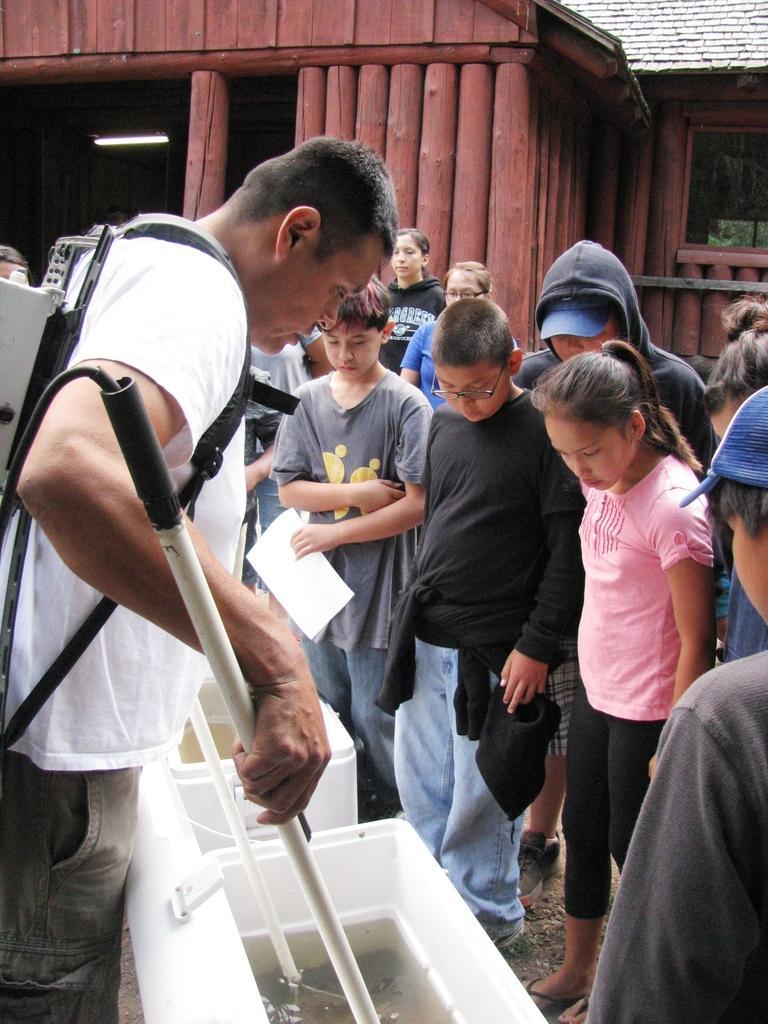In one or two sentences, can you explain what this image depicts? This picture is clicked outside. On the left there is a person wearing white color t-shirt, holding some object and standing on the ground. On the right we can see the group of people standing on the ground. In the center there are some white color objects placed on the ground. In the background we can see the houses. 